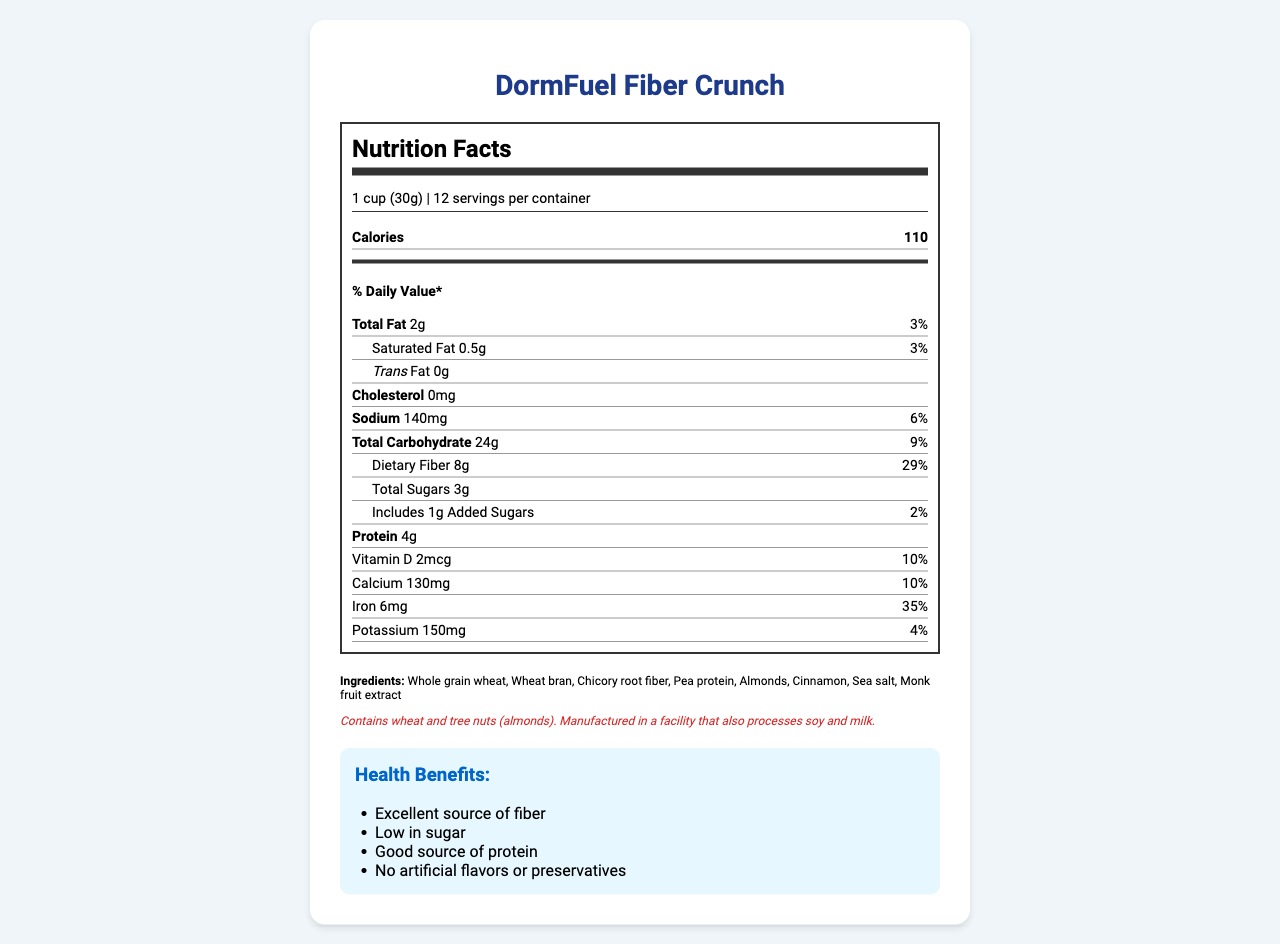What is the serving size for DormFuel Fiber Crunch? The serving size is located at the beginning of the nutrition label.
Answer: 1 cup (30g) How many grams of dietary fiber are in one serving of DormFuel Fiber Crunch? The dietary fiber content is listed under "Total Carbohydrate" in the nutrition label.
Answer: 8g What percentage of the daily value of iron does DormFuel Fiber Crunch provide? The percentage of daily value for iron is indicated in the nutrient section of the nutrition label.
Answer: 35% Does DormFuel Fiber Crunch contain any artificial flavors or preservatives? The health claims section explicitly states that it has "No artificial flavors or preservatives".
Answer: No What are the two main grains used in DormFuel Fiber Crunch? The ingredients list shows "Whole grain wheat" and "Wheat bran" among the top ingredients.
Answer: Whole grain wheat, Wheat bran Which of the following are recommended pairings for DormFuel Fiber Crunch? A. Muesli B. Fresh berries C. Greek yogurt D. Oregano B. Fresh berries and C. Greek yogurt are recommended in the suggested pairings section.
Answer: B and C What is the total amount of sugar in one serving, including added sugars? A. 1g B. 3g C. 8g D. 24g The label specifies "Total Sugars" as 3g and "Includes 1g Added Sugars," suggesting that the total sugars amount to 3g.
Answer: B. 3g Which nutrient has the highest daily value percentage per serving? A. Vitamin D B. Calcium C. Iron D. Potassium Iron has a daily value percentage of 35%, which is the highest among the listed nutrients.
Answer: C. Iron Is DormFuel Fiber Crunch low in sugar? The health claims section mentions "Low in sugar," reflecting the product's focus on being low-sugar.
Answer: Yes Summarize the nutritional and health benefits of DormFuel Fiber Crunch. This summary encompasses the main nutritional values, health claims, and intended benefits of the product as listed in the document.
Answer: DormFuel Fiber Crunch is a nutritious cereal designed for health-conscious individuals, especially dorm residents. Each serving (1 cup or 30g) contains 110 calories and is an excellent source of fiber (8g, 29% DV) while being low in sugar (3g total, including 1g added sugar). It also provides a good amount of protein (4g) and significant percentages of iron (35% DV), calcium (10% DV), and vitamin D (10% DV). The product is free from artificial flavors and preservatives and is ideal for maintaining steady energy levels, supporting digestive health, and catering to dietary concerns such as low sugar intake. What is the manufacturing allergen warning for DormFuel Fiber Crunch? The allergen information section provides details on potential allergens contained in the product and those processed in the same facility.
Answer: Contains wheat and tree nuts (almonds). Manufactured in a facility that also processes soy and milk. What is the sodium content per serving? The sodium content is listed under the nutrient section of the nutrition label.
Answer: 140mg Can the specific manufacturing plant for DormFuel Fiber Crunch be determined from the document? The document provides allergen information but does not specify the exact manufacturing plant.
Answer: Cannot be determined Is DormFuel Fiber Crunch a good source of protein? The health claims section states "Good source of protein," and the nutrient label supports this with 4g of protein per serving.
Answer: Yes 